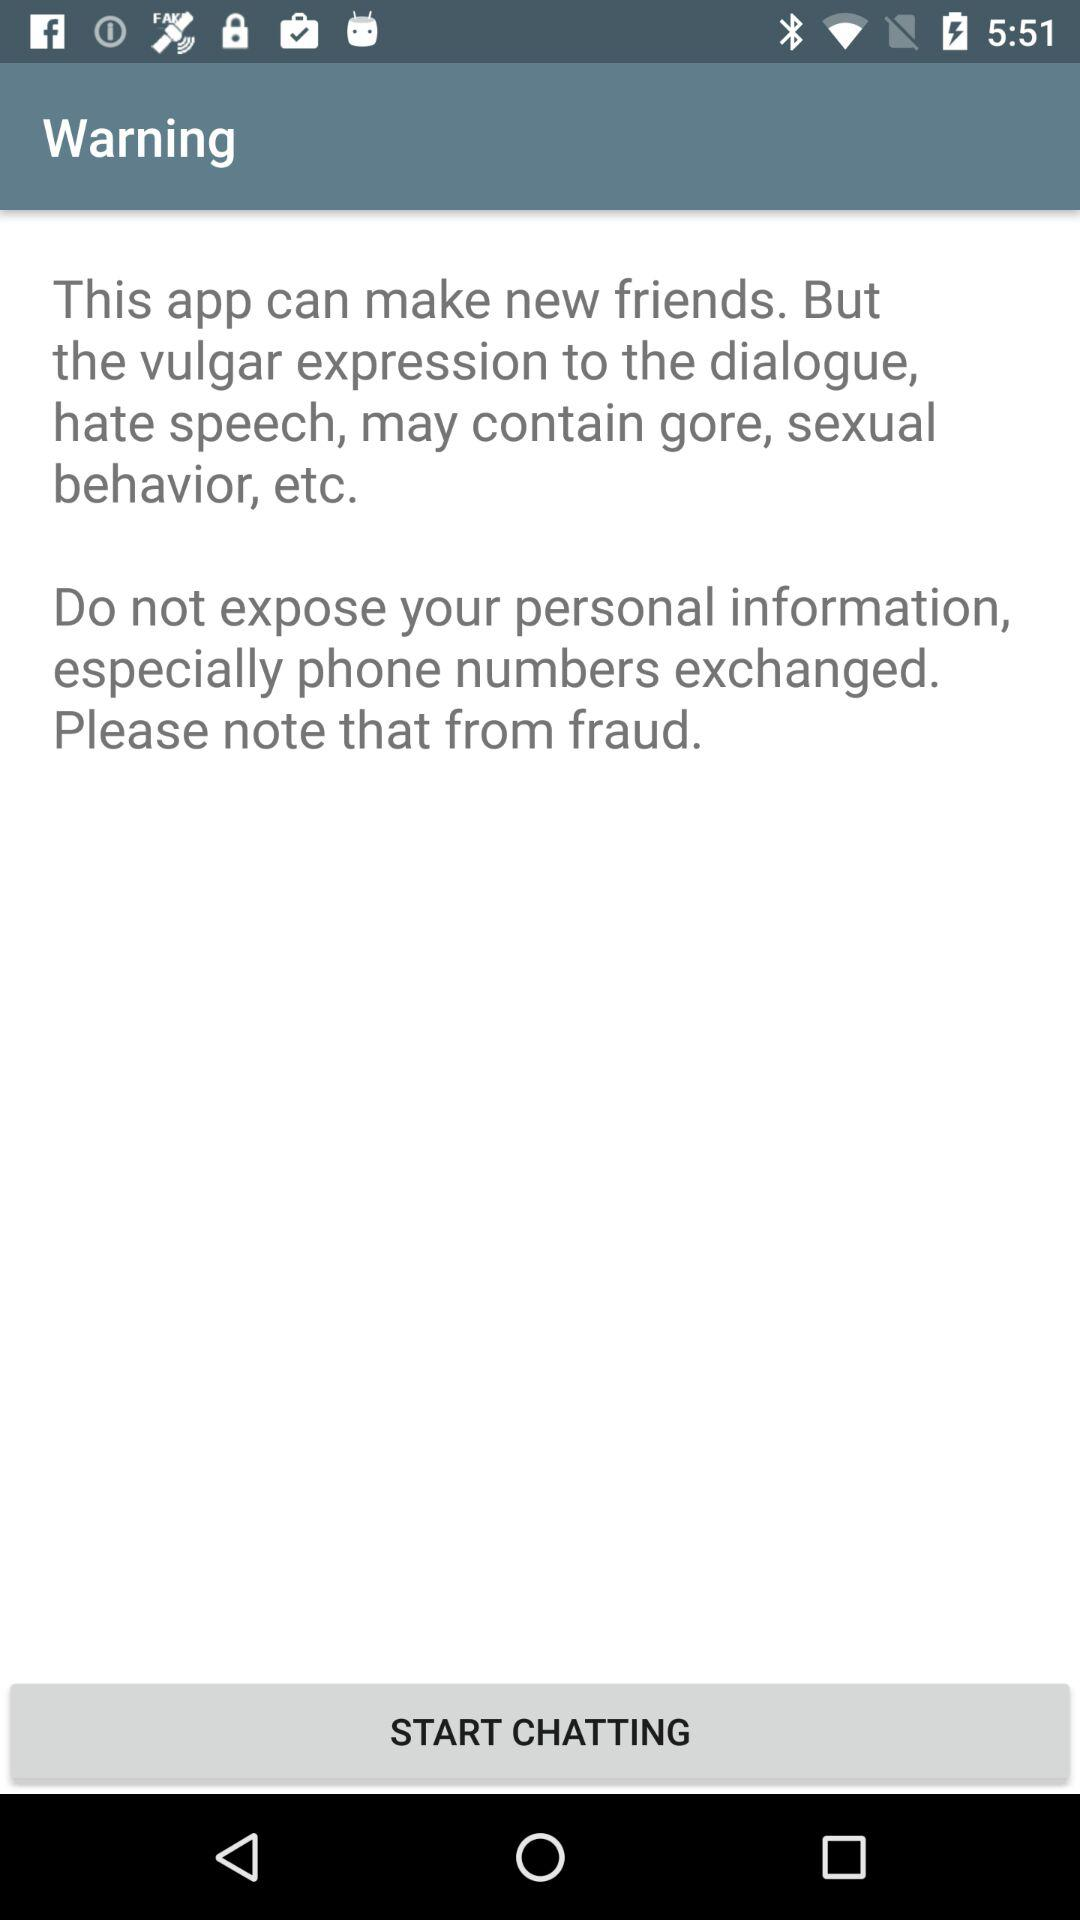How many warnings are displayed on the screen?
Answer the question using a single word or phrase. 2 